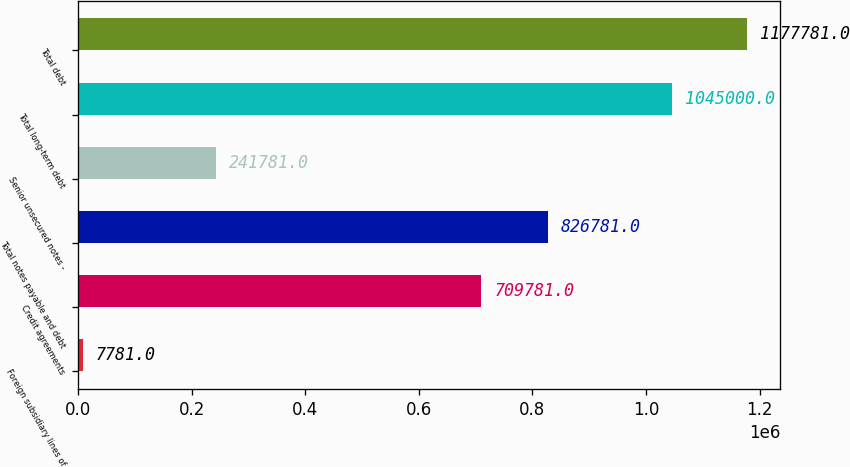Convert chart. <chart><loc_0><loc_0><loc_500><loc_500><bar_chart><fcel>Foreign subsidiary lines of<fcel>Credit agreements<fcel>Total notes payable and debt<fcel>Senior unsecured notes -<fcel>Total long-term debt<fcel>Total debt<nl><fcel>7781<fcel>709781<fcel>826781<fcel>241781<fcel>1.045e+06<fcel>1.17778e+06<nl></chart> 